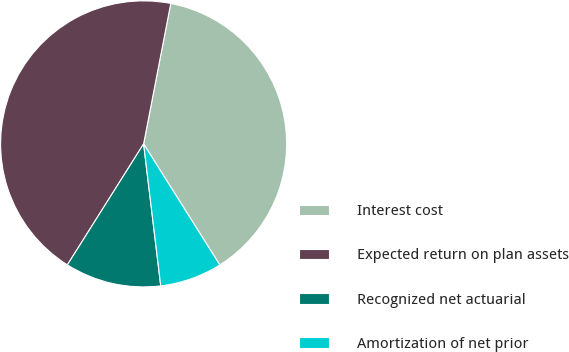Convert chart to OTSL. <chart><loc_0><loc_0><loc_500><loc_500><pie_chart><fcel>Interest cost<fcel>Expected return on plan assets<fcel>Recognized net actuarial<fcel>Amortization of net prior<nl><fcel>38.02%<fcel>44.09%<fcel>10.86%<fcel>7.03%<nl></chart> 